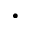Convert formula to latex. <formula><loc_0><loc_0><loc_500><loc_500>\cdot</formula> 